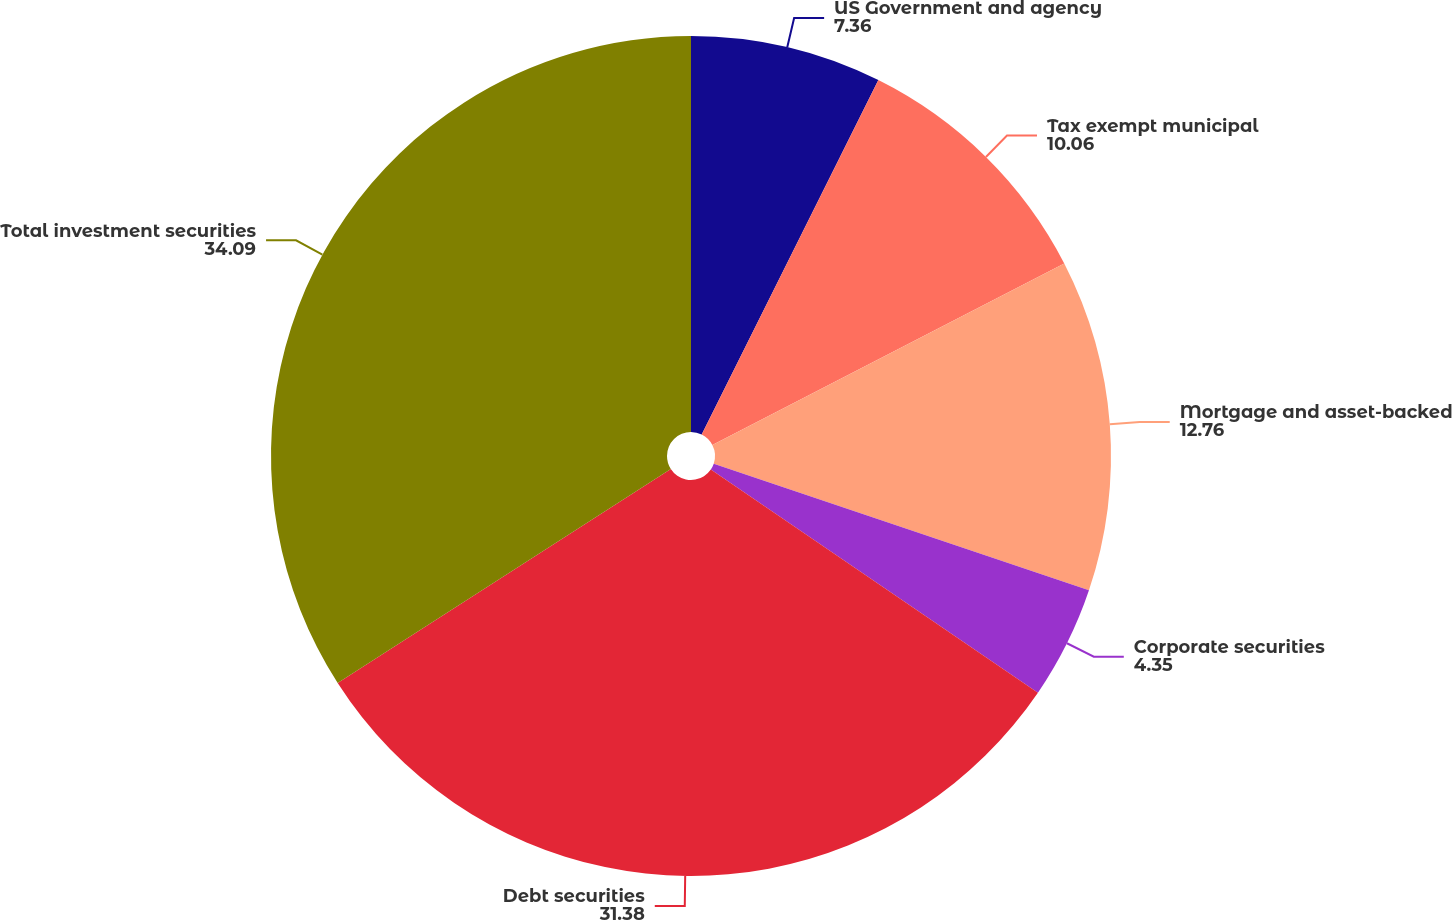Convert chart to OTSL. <chart><loc_0><loc_0><loc_500><loc_500><pie_chart><fcel>US Government and agency<fcel>Tax exempt municipal<fcel>Mortgage and asset-backed<fcel>Corporate securities<fcel>Debt securities<fcel>Total investment securities<nl><fcel>7.36%<fcel>10.06%<fcel>12.76%<fcel>4.35%<fcel>31.38%<fcel>34.09%<nl></chart> 